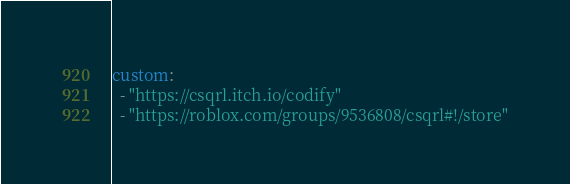Convert code to text. <code><loc_0><loc_0><loc_500><loc_500><_YAML_>custom:
  - "https://csqrl.itch.io/codify"
  - "https://roblox.com/groups/9536808/csqrl#!/store"
</code> 